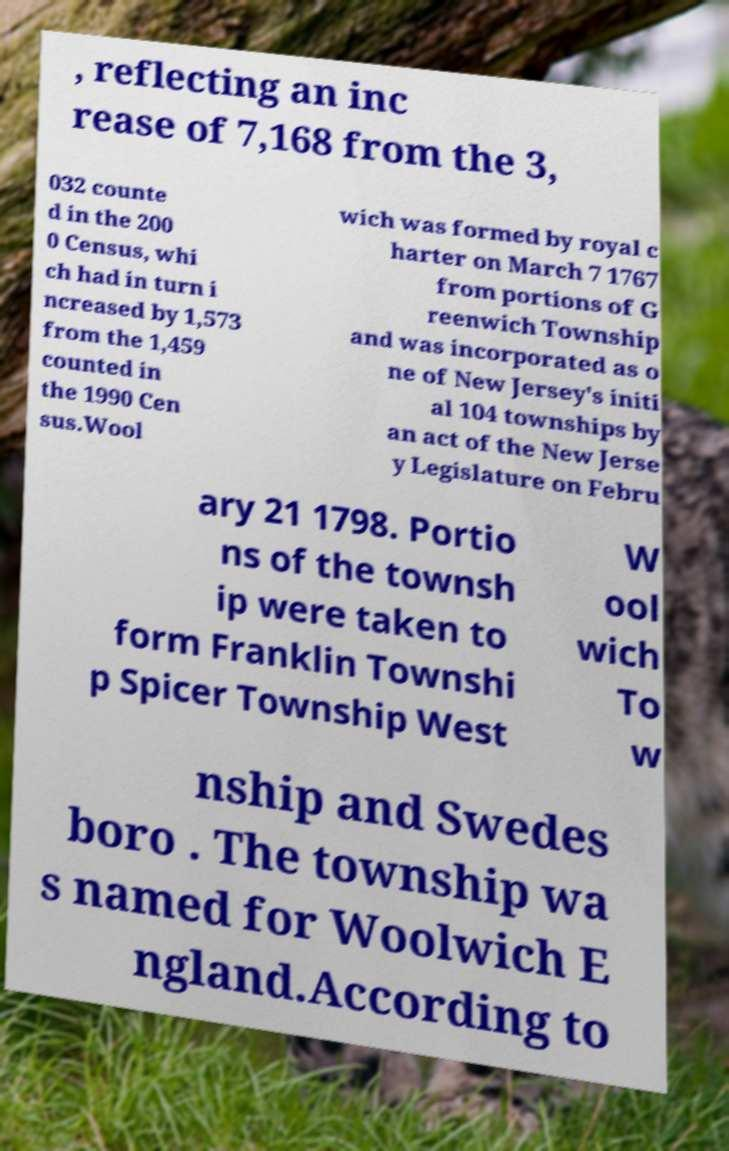Please identify and transcribe the text found in this image. , reflecting an inc rease of 7,168 from the 3, 032 counte d in the 200 0 Census, whi ch had in turn i ncreased by 1,573 from the 1,459 counted in the 1990 Cen sus.Wool wich was formed by royal c harter on March 7 1767 from portions of G reenwich Township and was incorporated as o ne of New Jersey's initi al 104 townships by an act of the New Jerse y Legislature on Febru ary 21 1798. Portio ns of the townsh ip were taken to form Franklin Townshi p Spicer Township West W ool wich To w nship and Swedes boro . The township wa s named for Woolwich E ngland.According to 